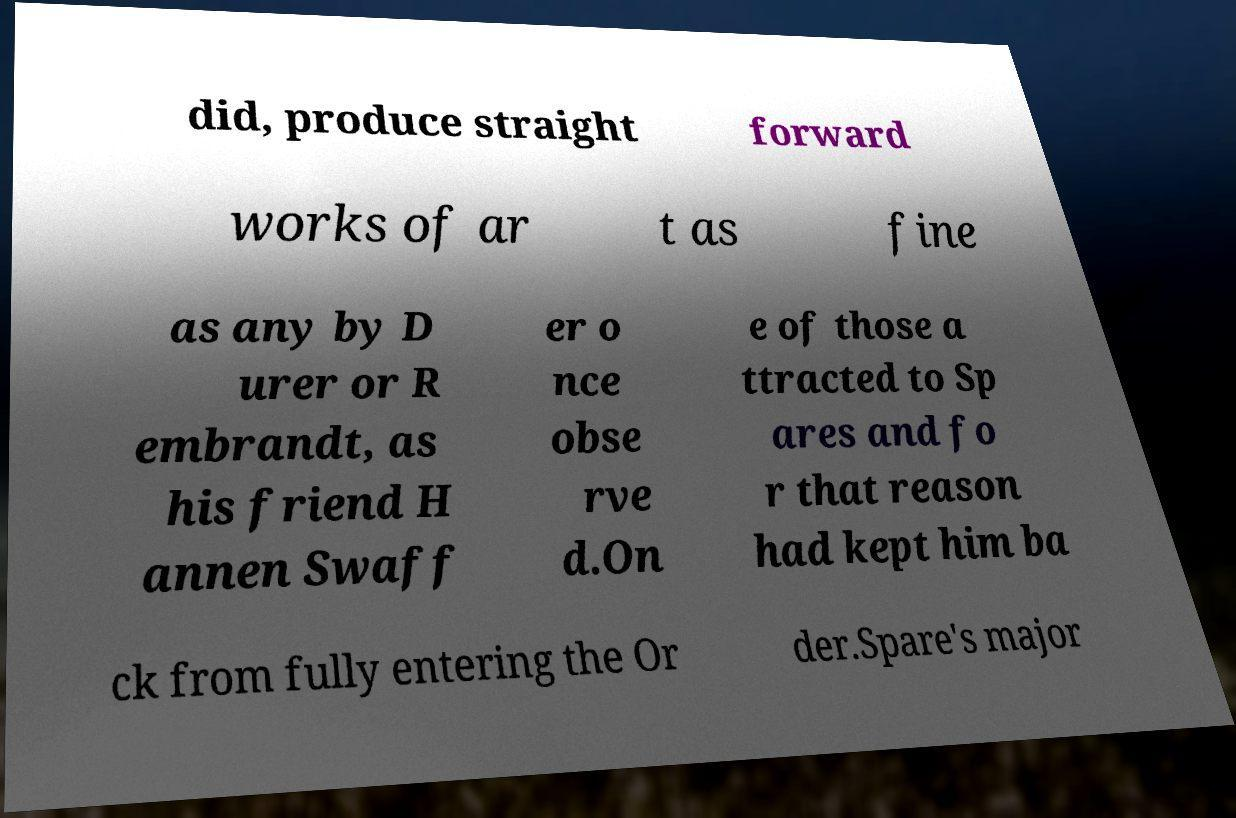There's text embedded in this image that I need extracted. Can you transcribe it verbatim? did, produce straight forward works of ar t as fine as any by D urer or R embrandt, as his friend H annen Swaff er o nce obse rve d.On e of those a ttracted to Sp ares and fo r that reason had kept him ba ck from fully entering the Or der.Spare's major 